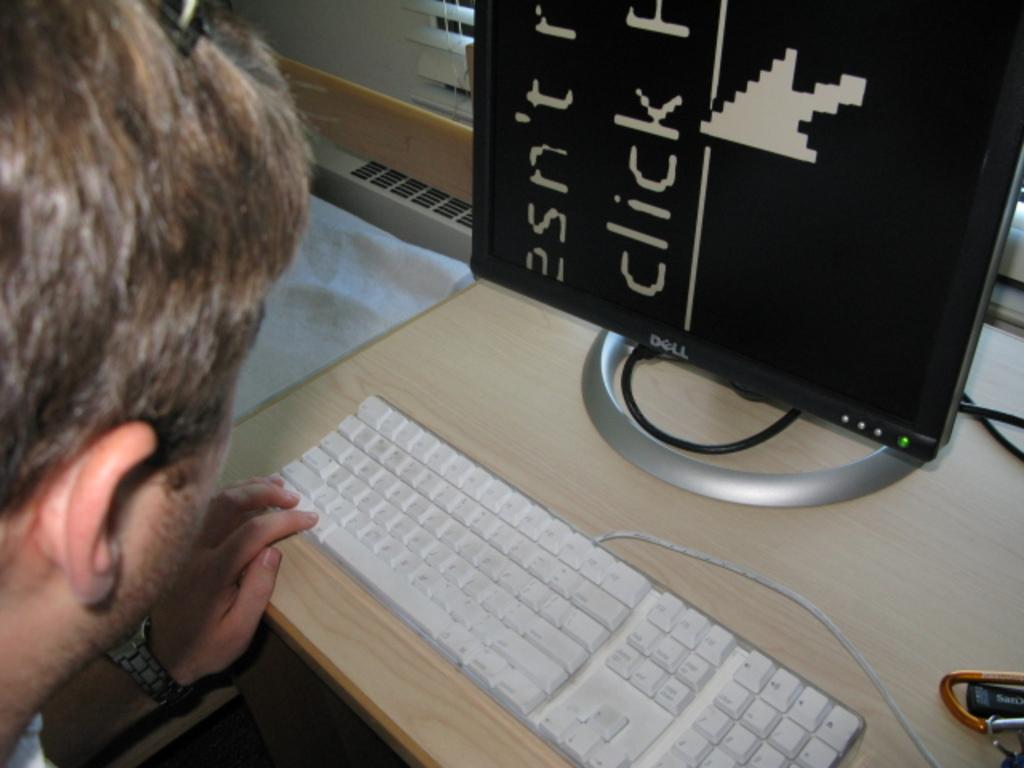What electronic device is visible in the image? There is a monitor in the image. What is the monitor connected to? There is a keyboard in the image, which is connected to the monitor. Where are the monitor and keyboard located? Both the monitor and keyboard are on a table. Can you describe the person in the image? The provided facts do not mention any details about the person in the image. What type of coal is being used by the person in the image? There is no coal present in the image. What type of apparel is the person wearing in the image? The provided facts do not mention any details about the person in the image, including their apparel. 